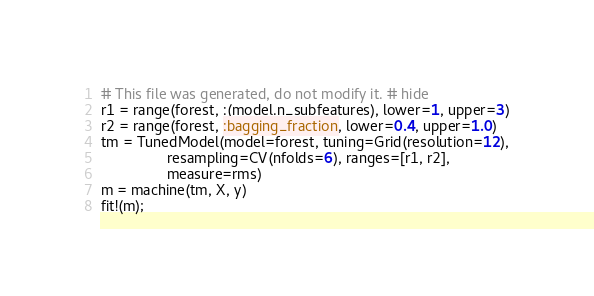Convert code to text. <code><loc_0><loc_0><loc_500><loc_500><_Julia_># This file was generated, do not modify it. # hide
r1 = range(forest, :(model.n_subfeatures), lower=1, upper=3)
r2 = range(forest, :bagging_fraction, lower=0.4, upper=1.0)
tm = TunedModel(model=forest, tuning=Grid(resolution=12),
                resampling=CV(nfolds=6), ranges=[r1, r2],
                measure=rms)
m = machine(tm, X, y)
fit!(m);</code> 